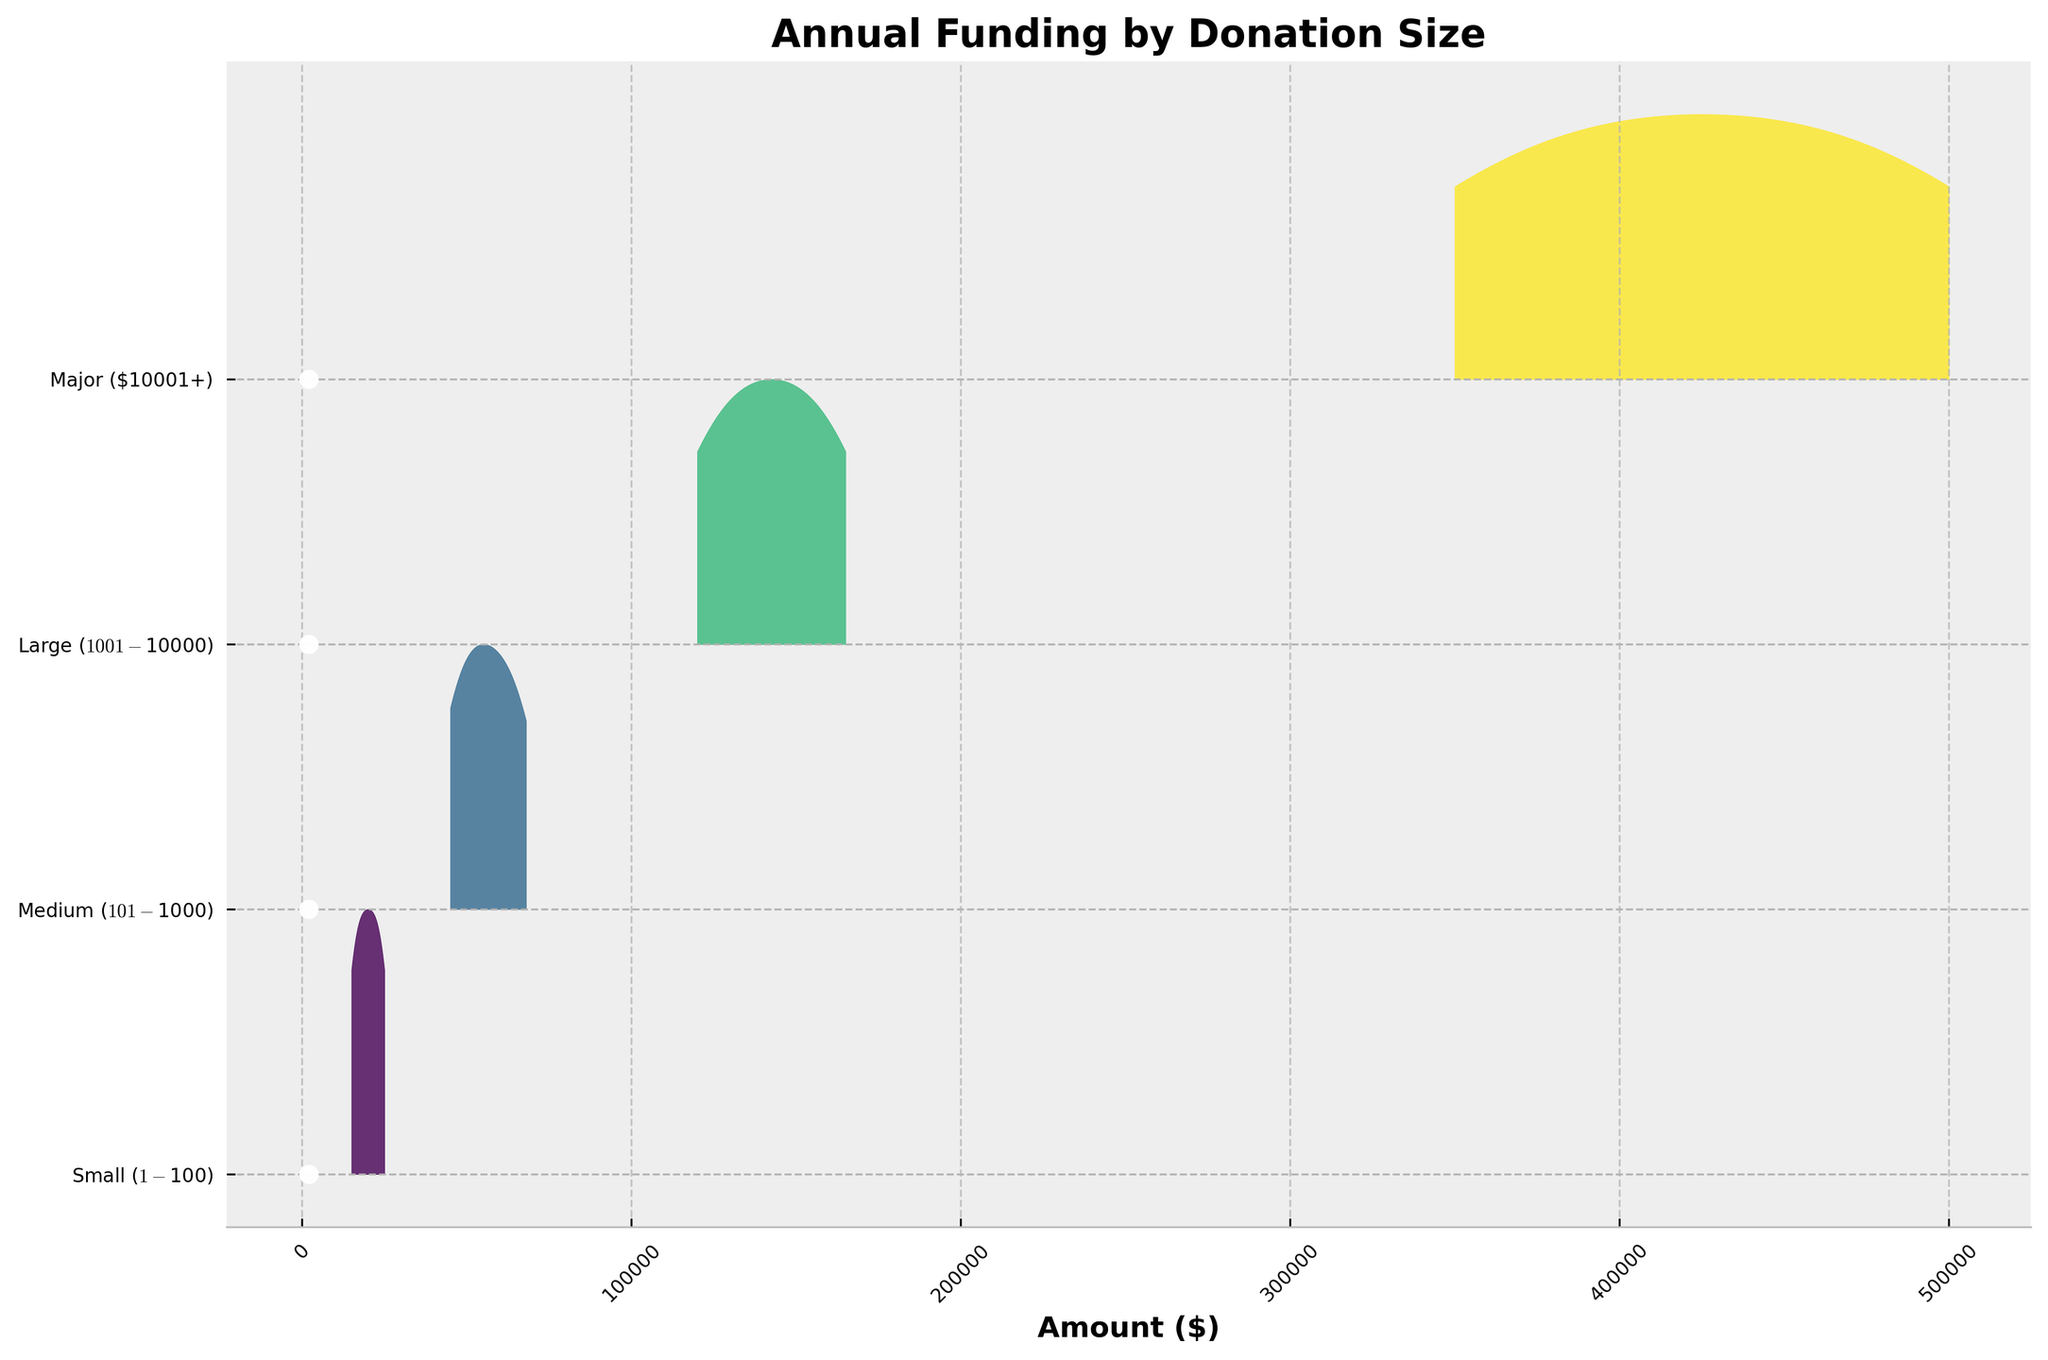How many categories of donation sizes are displayed on the plot? The plot shows different donation size categories on the y-axis. Each category represents a specific donation size range.
Answer: 4 What is the highest annual funding amount in the "Small ($1-$100)" donation size category? By looking at the filled ridgeline for "Small ($1-$100)", the highest amount can be identified on the x-axis.
Answer: $25,000 Which donation size category has the largest increase in funding from 2019 to 2022? To determine this, compare the start and end points of each donation size category. Calculate the difference between 2022 and 2019 for each category.
Answer: Major ($10001+) How does the "Medium ($101-$1000)" category's funding trend appear over the years? The trend can be assessed by observing the filled area and the points plotted for each year. Note if the funding is increasing or decreasing over time.
Answer: Increasing What's the difference in funding amounts between the "Large ($1001-$10000)" and "Major ($10001+)" categories in 2021? Find the values on the x-axis for both categories in 2021, then subtract the amount for "Large ($1001-$10000)" from "Major ($10001+)".
Answer: $300,000 Which year shows the highest density of funding for the "Major ($10001+)" category? By examining the filled ridgeline for the "Major ($10001+)" category, the year with the highest peak in the filled area indicates the year with the highest density.
Answer: 2022 How does the range of values for "Small ($1-$100)" compare to "Medium ($101-$1000)" in 2020? Compare the start and end points of the filled areas for these categories in 2020 by looking at the range on the x-axis.
Answer: Smaller range for "Small" In 2019, did any donation size category receive less than $20,000? Check the furthest left point of the ridgeline plots in 2019.
Answer: Yes, "Small ($1-$100)" What is the average funding amount over the years for the "Large ($1001-$10000)" category? Sum the funding amounts for "Large ($1001-$10000)" from 2019 to 2022 and then divide by the number of years.
Answer: $142,500 Is the funding trend for "Major ($10001+)" linear or non-linear? Assess the distribution and changes in peaks for the "Major ($10001+)" category.
Answer: Linear 